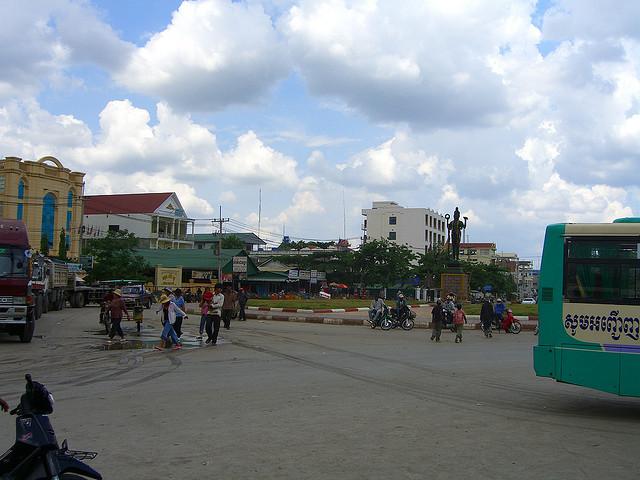What kind of bus is here?
Short answer required. Passenger. What is the blue item on the left?
Keep it brief. Window. What is the color of the clouds?
Write a very short answer. White. Is the ground damp?
Keep it brief. No. How many people in the picture?
Be succinct. 15. How many people are riding the motorcycles?
Keep it brief. 3. What is the yellow thing in the background?
Answer briefly. Building. What is the weather like?
Concise answer only. Cloudy. Is there an RV behind the bus?
Give a very brief answer. No. What color is the bumper of the bus?
Short answer required. Teal. What time is it?
Be succinct. Daytime. Is there a lot of traffic?
Quick response, please. No. What country is this in?
Write a very short answer. India. Are there any people?
Write a very short answer. Yes. What is on the ground around the fire hydrant?
Short answer required. Dirt. How many buses are in the parking lot?
Give a very brief answer. 1. How many yellow signs are in the photo?
Short answer required. 1. Is it day or night?
Concise answer only. Day. Could there be an emergency?
Concise answer only. No. Is this place filled with water?
Concise answer only. No. How many buildings are visible?
Short answer required. 3. Is there a truck?
Write a very short answer. Yes. 